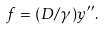<formula> <loc_0><loc_0><loc_500><loc_500>f = ( D / \gamma ) y ^ { \prime \prime } .</formula> 